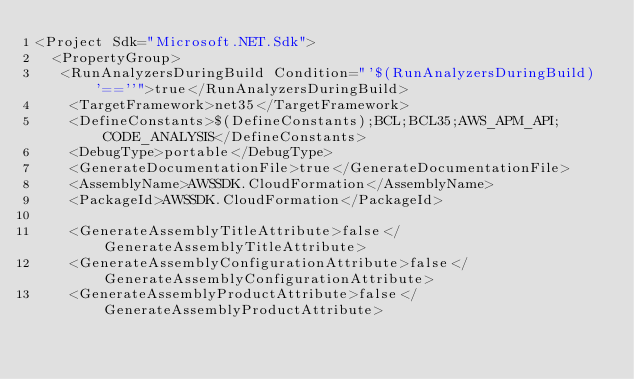Convert code to text. <code><loc_0><loc_0><loc_500><loc_500><_XML_><Project Sdk="Microsoft.NET.Sdk">
  <PropertyGroup>
   <RunAnalyzersDuringBuild Condition="'$(RunAnalyzersDuringBuild)'==''">true</RunAnalyzersDuringBuild>
    <TargetFramework>net35</TargetFramework>
    <DefineConstants>$(DefineConstants);BCL;BCL35;AWS_APM_API;CODE_ANALYSIS</DefineConstants>
    <DebugType>portable</DebugType>
    <GenerateDocumentationFile>true</GenerateDocumentationFile>
    <AssemblyName>AWSSDK.CloudFormation</AssemblyName>
    <PackageId>AWSSDK.CloudFormation</PackageId>

    <GenerateAssemblyTitleAttribute>false</GenerateAssemblyTitleAttribute>
    <GenerateAssemblyConfigurationAttribute>false</GenerateAssemblyConfigurationAttribute>
    <GenerateAssemblyProductAttribute>false</GenerateAssemblyProductAttribute></code> 